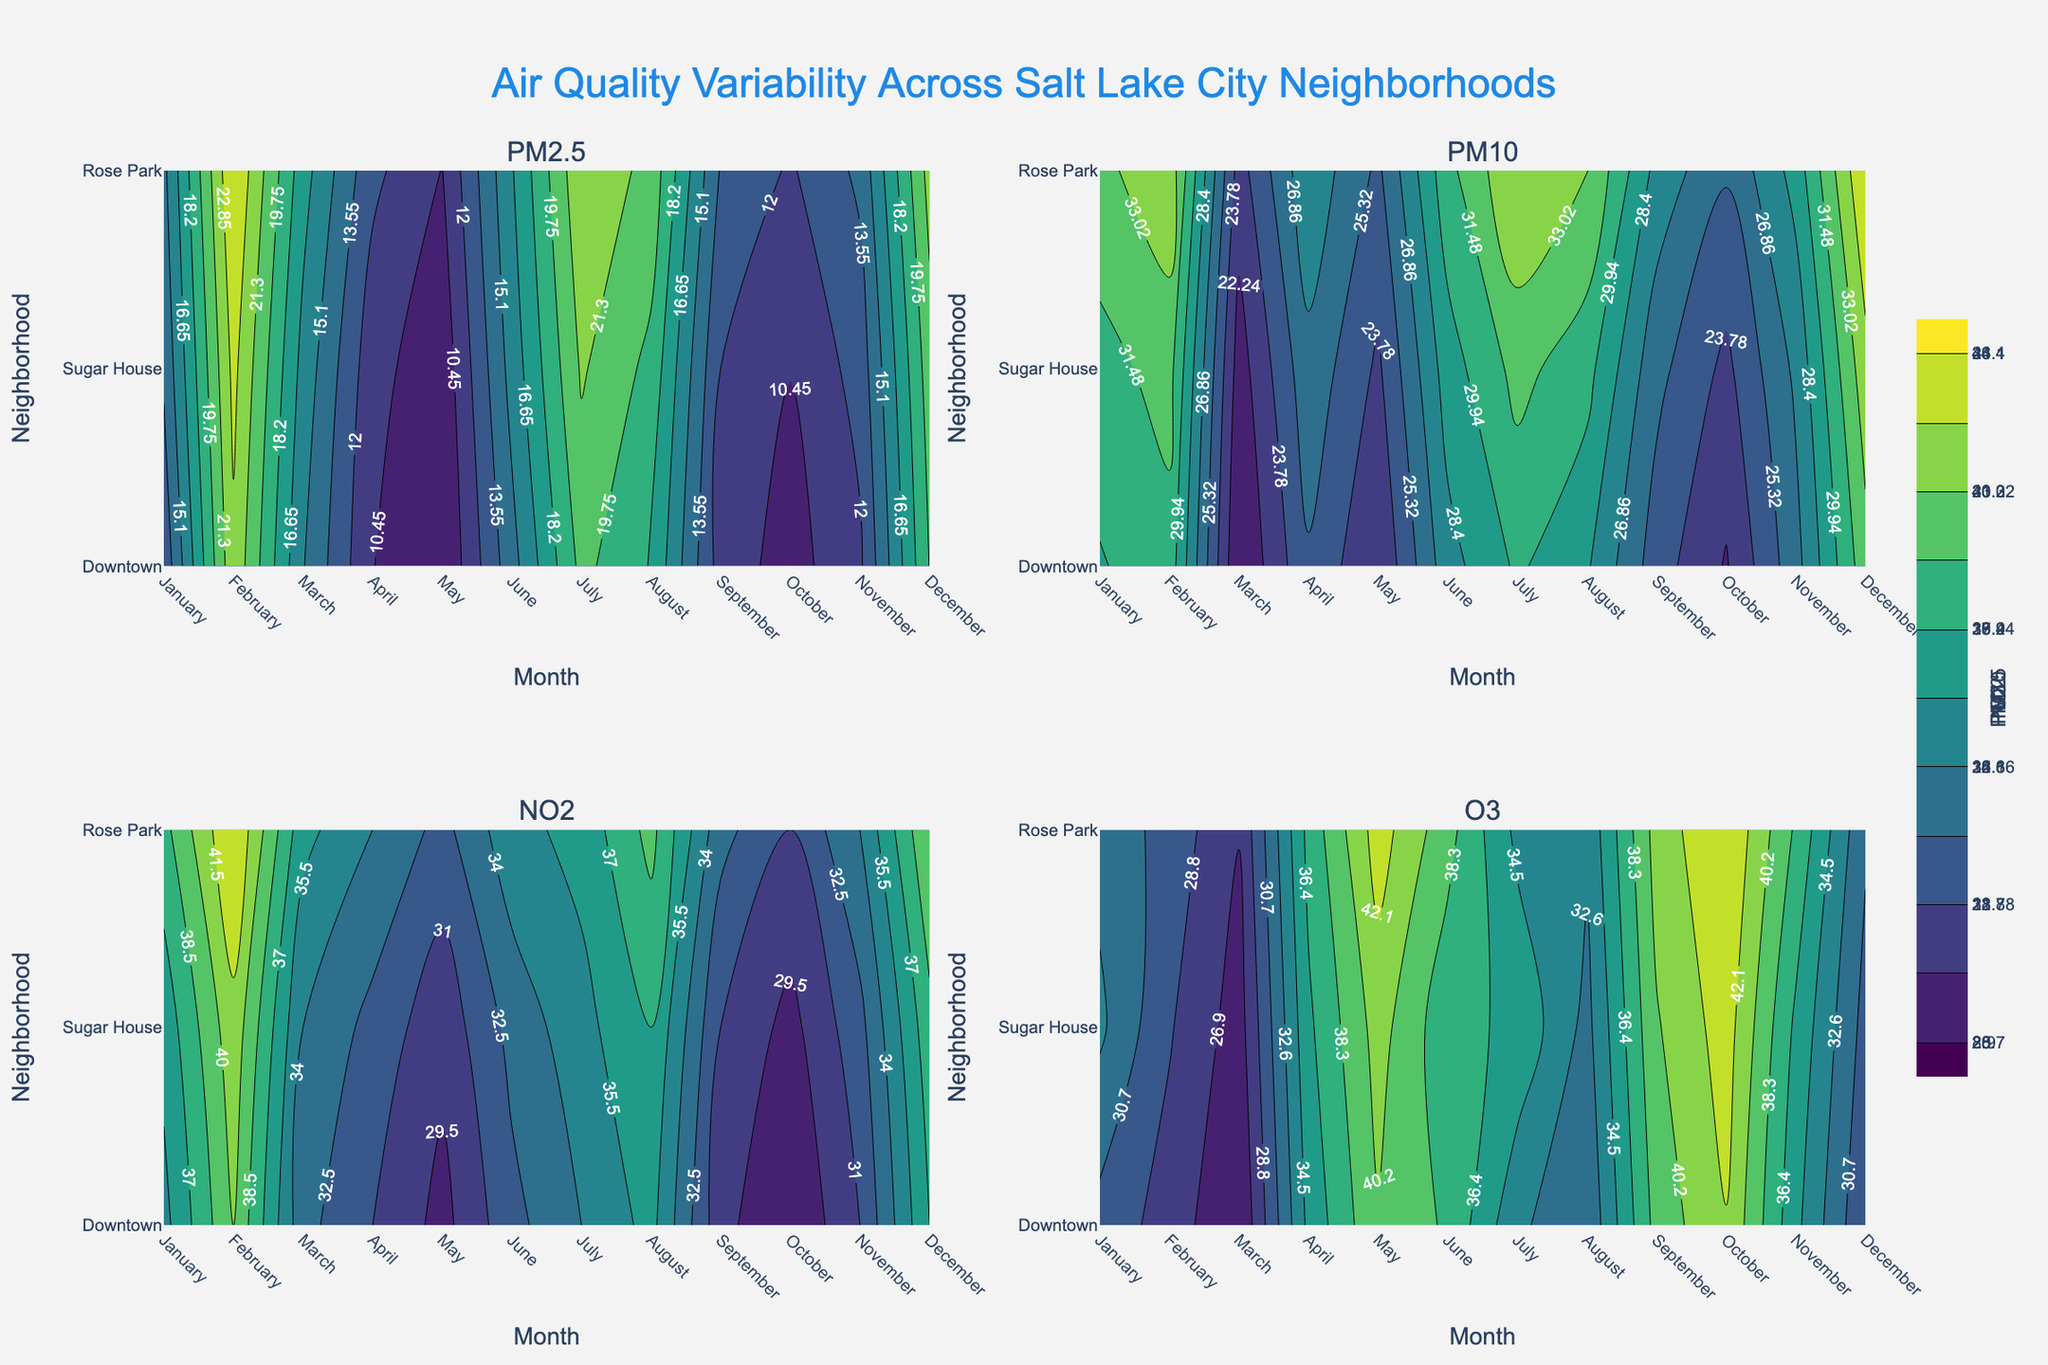What is the title of the figure? The title of the figure is usually placed at the top center. Looking at the designated area, the title reads "Air Quality Variability Across Salt Lake City Neighborhoods".
Answer: Air Quality Variability Across Salt Lake City Neighborhoods Which pollutants are shown in the subplots? The subplot titles indicate the pollutants being analyzed. They are "PM2.5", "PM10", "NO2", and "O3".
Answer: PM2.5, PM10, NO2, O3 Which neighborhood has the highest PM2.5 level in July? By inspecting the contour plot of PM2.5, we can look at the value corresponding to July. The neighborhood with the darkest color point indicates the highest level, which is "Rose Park" with a level of around 22.6.
Answer: Rose Park How does the NO2 level in March compare between Downtown and Rose Park? Checking the NO2 subplot, look at March and compare the values for Downtown and Rose Park. Downtown has a level of 33, while Rose Park has 36. Rose Park has a higher level than Downtown.
Answer: Rose Park has higher NO2 in March In which month does Sugar House have the highest O3 level? Observing the O3 contour subplot for Sugar House across the months, the brightest color appears in October, indicating the highest level. The value is 43.
Answer: October How does the PM10 level change in Downtown from January to December? Following the PM10 subplot for Downtown from January to December, we see an increase from 29.8 to 32.4. The graph shows a slight upward trend in the contour plot, indicating an overall increase.
Answer: Increased Which pollutant shows the most variability across neighborhoods in November? Looking at the contour plots for November and comparing the range of values across neighborhoods for each pollutant, PM10 shows significant variability, as indicated by the color gradient differences.
Answer: PM10 What is the average PM2.5 level in September across all neighborhoods? Identify the PM2.5 values for September in all neighborhoods: Downtown (11.3), Sugar House (12.0), and Rose Park (13.4). Sum and divide by the number of neighborhoods: (11.3 + 12.0 + 13.4) / 3 = 12.23.
Answer: 12.23 Which neighborhood experienced the highest NO2 level in the entire year? Examine the NO2 contour plot to identify the section with the darkest color across all months and neighborhoods. Rose Park has the highest level at 43 in February.
Answer: Rose Park What seasonal pattern can you identify in the O3 levels across the neighborhoods? By looking at the O3 subplot, the darker colors in colder months (November through February) and lighter colors in warmer months (May through August) indicate higher levels of O3 in the warmer months. This suggests a seasonal pattern where O3 levels peak during summer and decline in winter.
Answer: Higher in summer, lower in winter 